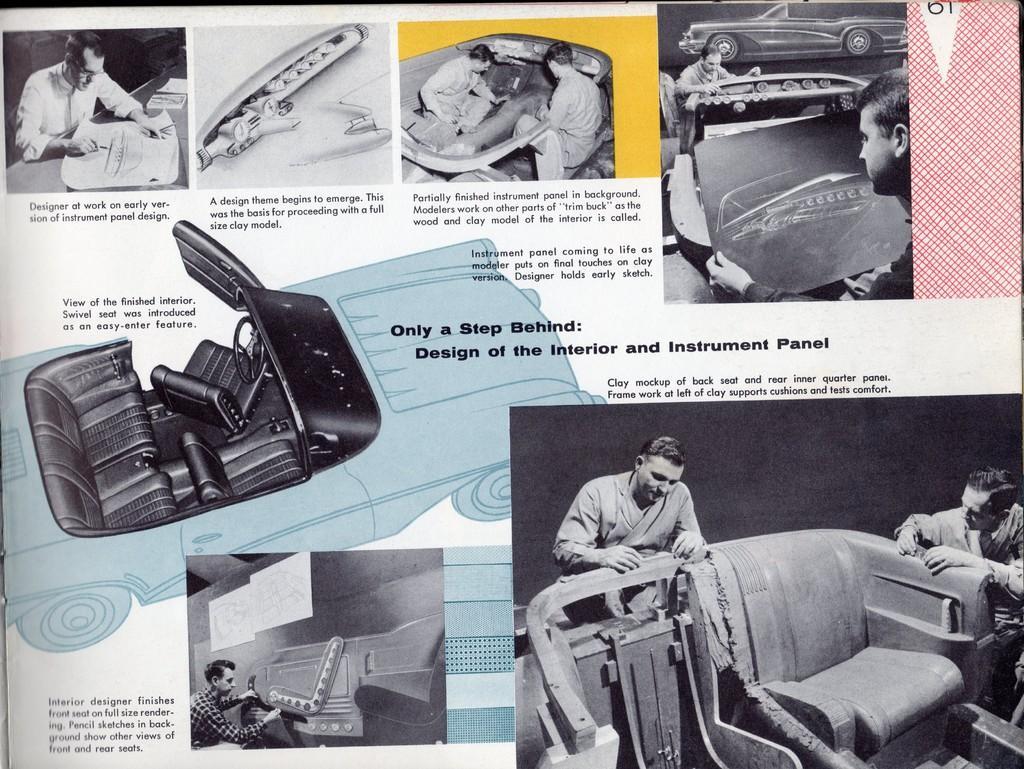Please provide a concise description of this image. In this image we can see a paper with text. Also there are images of people, vehicles and some other objects. 